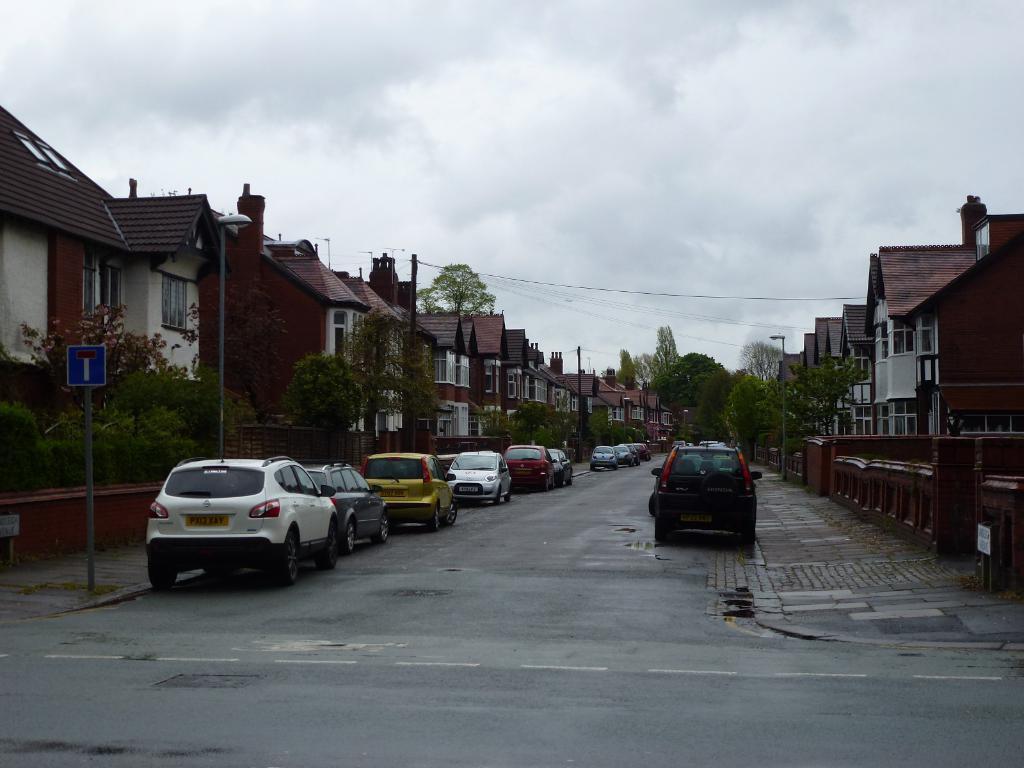Could you give a brief overview of what you see in this image? This is a street view, in this image there are cars parked on the road, on the either side of the road there are sign boards, trees and buildings. 